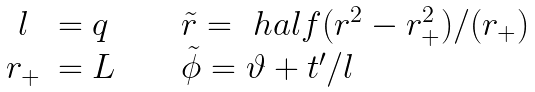<formula> <loc_0><loc_0><loc_500><loc_500>\begin{array} { c l c l } l & = q & \quad & \tilde { r } = \ h a l f ( r ^ { 2 } - r _ { + } ^ { 2 } ) / ( r _ { + } ) \\ r _ { + } & = L & \quad & \tilde { \phi } = \vartheta + t ^ { \prime } / l \end{array}</formula> 